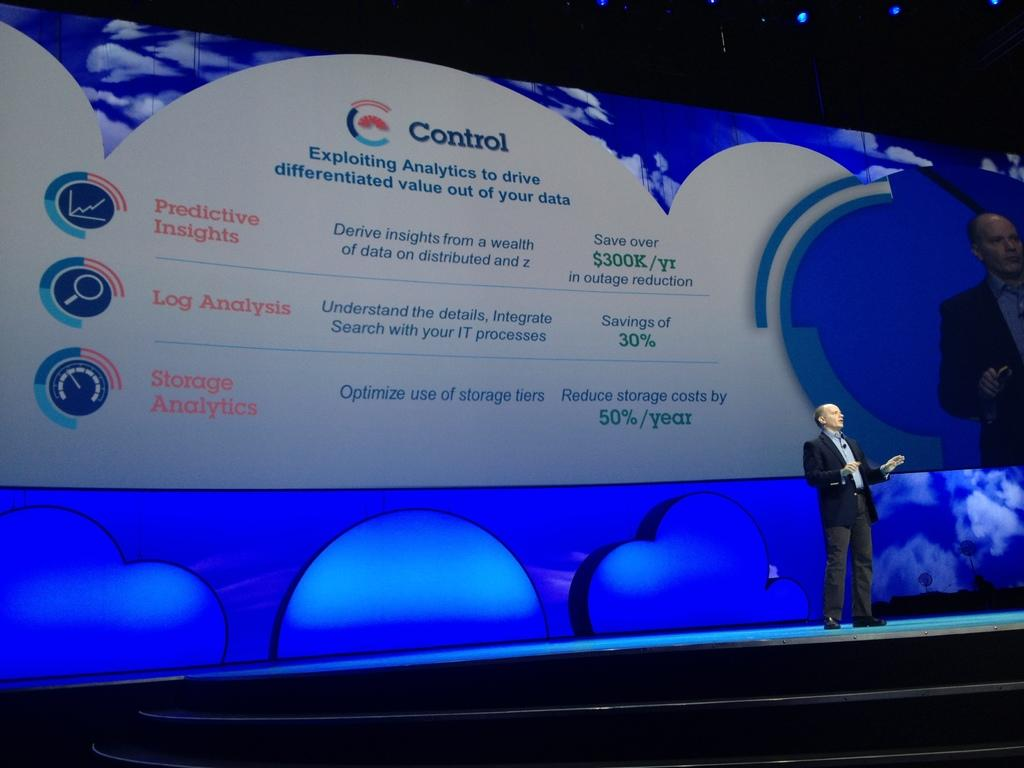Provide a one-sentence caption for the provided image. A presentation about making your data be more beneficial and profitable to you. 